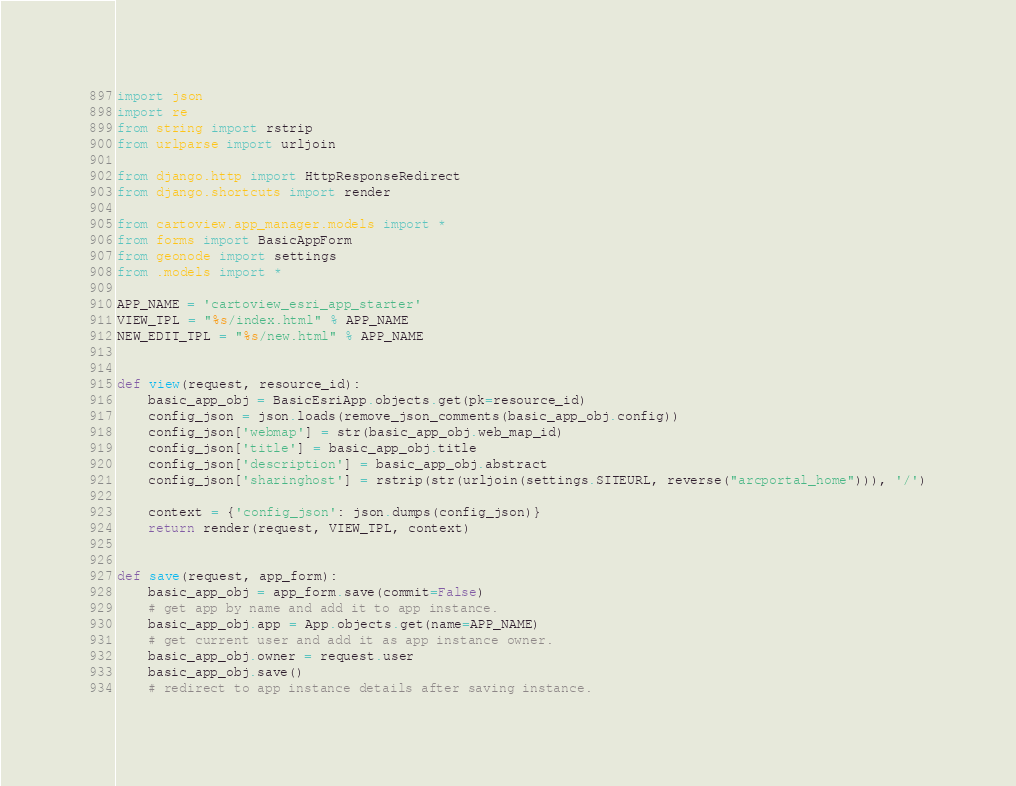<code> <loc_0><loc_0><loc_500><loc_500><_Python_>import json
import re
from string import rstrip
from urlparse import urljoin

from django.http import HttpResponseRedirect
from django.shortcuts import render

from cartoview.app_manager.models import *
from forms import BasicAppForm
from geonode import settings
from .models import *

APP_NAME = 'cartoview_esri_app_starter'
VIEW_TPL = "%s/index.html" % APP_NAME
NEW_EDIT_TPL = "%s/new.html" % APP_NAME


def view(request, resource_id):
    basic_app_obj = BasicEsriApp.objects.get(pk=resource_id)
    config_json = json.loads(remove_json_comments(basic_app_obj.config))
    config_json['webmap'] = str(basic_app_obj.web_map_id)
    config_json['title'] = basic_app_obj.title
    config_json['description'] = basic_app_obj.abstract
    config_json['sharinghost'] = rstrip(str(urljoin(settings.SITEURL, reverse("arcportal_home"))), '/')

    context = {'config_json': json.dumps(config_json)}
    return render(request, VIEW_TPL, context)


def save(request, app_form):
    basic_app_obj = app_form.save(commit=False)
    # get app by name and add it to app instance.
    basic_app_obj.app = App.objects.get(name=APP_NAME)
    # get current user and add it as app instance owner.
    basic_app_obj.owner = request.user
    basic_app_obj.save()
    # redirect to app instance details after saving instance.</code> 